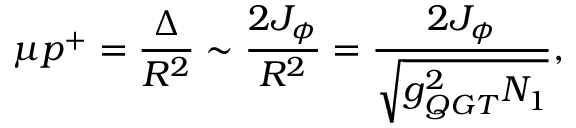<formula> <loc_0><loc_0><loc_500><loc_500>\mu p ^ { + } = \frac { \Delta } { R ^ { 2 } } \sim \frac { 2 J _ { \phi } } { R ^ { 2 } } = \frac { 2 J _ { \phi } } { \sqrt { g _ { Q G T } ^ { 2 } N _ { 1 } } } ,</formula> 